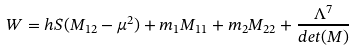Convert formula to latex. <formula><loc_0><loc_0><loc_500><loc_500>W = h S ( M _ { 1 2 } - \mu ^ { 2 } ) + m _ { 1 } M _ { 1 1 } + m _ { 2 } M _ { 2 2 } + \frac { \Lambda ^ { 7 } } { d e t ( M ) }</formula> 